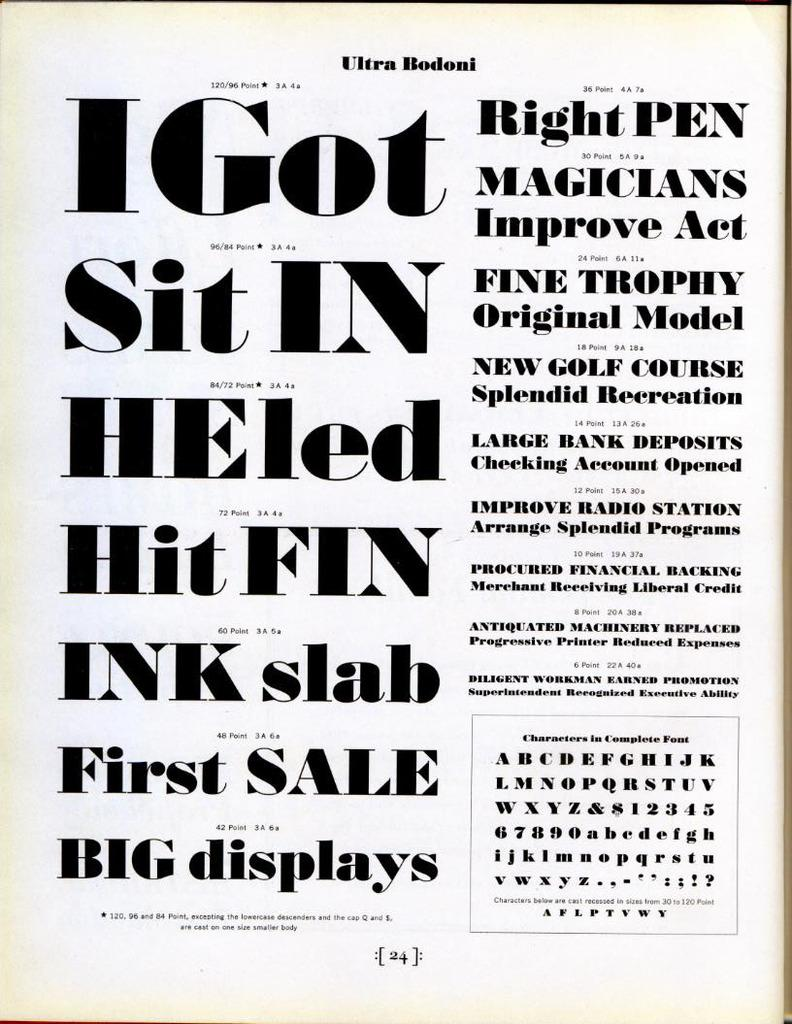<image>
Render a clear and concise summary of the photo. Many letters are on a page titled Ultra Bodoni. 